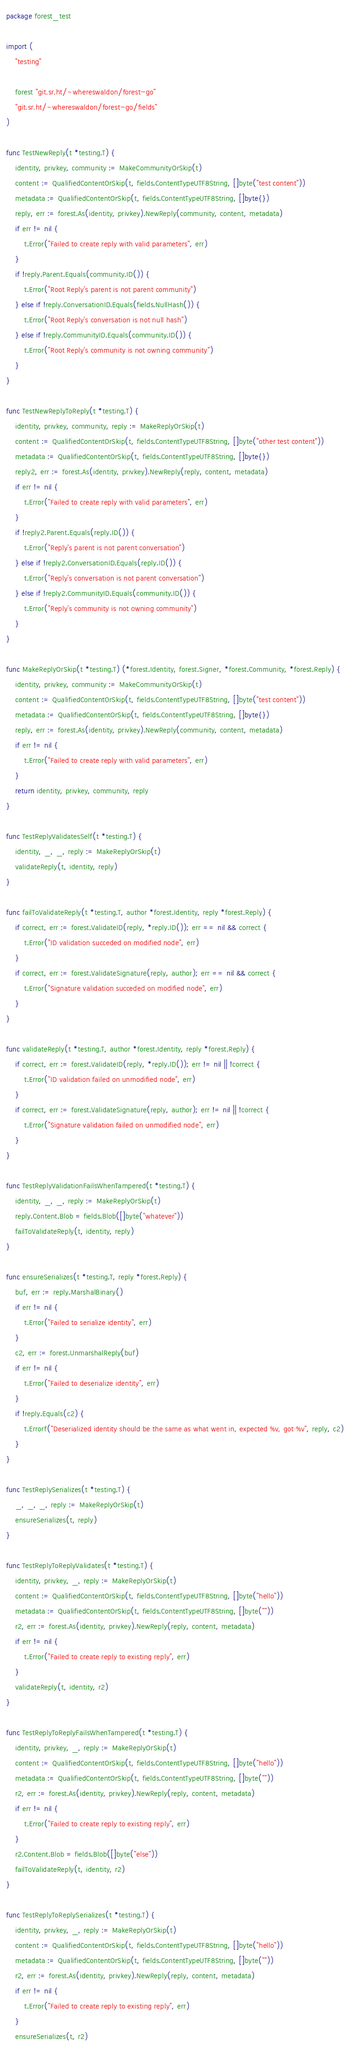Convert code to text. <code><loc_0><loc_0><loc_500><loc_500><_Go_>package forest_test

import (
	"testing"

	forest "git.sr.ht/~whereswaldon/forest-go"
	"git.sr.ht/~whereswaldon/forest-go/fields"
)

func TestNewReply(t *testing.T) {
	identity, privkey, community := MakeCommunityOrSkip(t)
	content := QualifiedContentOrSkip(t, fields.ContentTypeUTF8String, []byte("test content"))
	metadata := QualifiedContentOrSkip(t, fields.ContentTypeUTF8String, []byte{})
	reply, err := forest.As(identity, privkey).NewReply(community, content, metadata)
	if err != nil {
		t.Error("Failed to create reply with valid parameters", err)
	}
	if !reply.Parent.Equals(community.ID()) {
		t.Error("Root Reply's parent is not parent community")
	} else if !reply.ConversationID.Equals(fields.NullHash()) {
		t.Error("Root Reply's conversation is not null hash")
	} else if !reply.CommunityID.Equals(community.ID()) {
		t.Error("Root Reply's community is not owning community")
	}
}

func TestNewReplyToReply(t *testing.T) {
	identity, privkey, community, reply := MakeReplyOrSkip(t)
	content := QualifiedContentOrSkip(t, fields.ContentTypeUTF8String, []byte("other test content"))
	metadata := QualifiedContentOrSkip(t, fields.ContentTypeUTF8String, []byte{})
	reply2, err := forest.As(identity, privkey).NewReply(reply, content, metadata)
	if err != nil {
		t.Error("Failed to create reply with valid parameters", err)
	}
	if !reply2.Parent.Equals(reply.ID()) {
		t.Error("Reply's parent is not parent conversation")
	} else if !reply2.ConversationID.Equals(reply.ID()) {
		t.Error("Reply's conversation is not parent conversation")
	} else if !reply2.CommunityID.Equals(community.ID()) {
		t.Error("Reply's community is not owning community")
	}
}

func MakeReplyOrSkip(t *testing.T) (*forest.Identity, forest.Signer, *forest.Community, *forest.Reply) {
	identity, privkey, community := MakeCommunityOrSkip(t)
	content := QualifiedContentOrSkip(t, fields.ContentTypeUTF8String, []byte("test content"))
	metadata := QualifiedContentOrSkip(t, fields.ContentTypeUTF8String, []byte{})
	reply, err := forest.As(identity, privkey).NewReply(community, content, metadata)
	if err != nil {
		t.Error("Failed to create reply with valid parameters", err)
	}
	return identity, privkey, community, reply
}

func TestReplyValidatesSelf(t *testing.T) {
	identity, _, _, reply := MakeReplyOrSkip(t)
	validateReply(t, identity, reply)
}

func failToValidateReply(t *testing.T, author *forest.Identity, reply *forest.Reply) {
	if correct, err := forest.ValidateID(reply, *reply.ID()); err == nil && correct {
		t.Error("ID validation succeded on modified node", err)
	}
	if correct, err := forest.ValidateSignature(reply, author); err == nil && correct {
		t.Error("Signature validation succeded on modified node", err)
	}
}

func validateReply(t *testing.T, author *forest.Identity, reply *forest.Reply) {
	if correct, err := forest.ValidateID(reply, *reply.ID()); err != nil || !correct {
		t.Error("ID validation failed on unmodified node", err)
	}
	if correct, err := forest.ValidateSignature(reply, author); err != nil || !correct {
		t.Error("Signature validation failed on unmodified node", err)
	}
}

func TestReplyValidationFailsWhenTampered(t *testing.T) {
	identity, _, _, reply := MakeReplyOrSkip(t)
	reply.Content.Blob = fields.Blob([]byte("whatever"))
	failToValidateReply(t, identity, reply)
}

func ensureSerializes(t *testing.T, reply *forest.Reply) {
	buf, err := reply.MarshalBinary()
	if err != nil {
		t.Error("Failed to serialize identity", err)
	}
	c2, err := forest.UnmarshalReply(buf)
	if err != nil {
		t.Error("Failed to deserialize identity", err)
	}
	if !reply.Equals(c2) {
		t.Errorf("Deserialized identity should be the same as what went in, expected %v, got %v", reply, c2)
	}
}

func TestReplySerializes(t *testing.T) {
	_, _, _, reply := MakeReplyOrSkip(t)
	ensureSerializes(t, reply)
}

func TestReplyToReplyValidates(t *testing.T) {
	identity, privkey, _, reply := MakeReplyOrSkip(t)
	content := QualifiedContentOrSkip(t, fields.ContentTypeUTF8String, []byte("hello"))
	metadata := QualifiedContentOrSkip(t, fields.ContentTypeUTF8String, []byte(""))
	r2, err := forest.As(identity, privkey).NewReply(reply, content, metadata)
	if err != nil {
		t.Error("Failed to create reply to existing reply", err)
	}
	validateReply(t, identity, r2)
}

func TestReplyToReplyFailsWhenTampered(t *testing.T) {
	identity, privkey, _, reply := MakeReplyOrSkip(t)
	content := QualifiedContentOrSkip(t, fields.ContentTypeUTF8String, []byte("hello"))
	metadata := QualifiedContentOrSkip(t, fields.ContentTypeUTF8String, []byte(""))
	r2, err := forest.As(identity, privkey).NewReply(reply, content, metadata)
	if err != nil {
		t.Error("Failed to create reply to existing reply", err)
	}
	r2.Content.Blob = fields.Blob([]byte("else"))
	failToValidateReply(t, identity, r2)
}

func TestReplyToReplySerializes(t *testing.T) {
	identity, privkey, _, reply := MakeReplyOrSkip(t)
	content := QualifiedContentOrSkip(t, fields.ContentTypeUTF8String, []byte("hello"))
	metadata := QualifiedContentOrSkip(t, fields.ContentTypeUTF8String, []byte(""))
	r2, err := forest.As(identity, privkey).NewReply(reply, content, metadata)
	if err != nil {
		t.Error("Failed to create reply to existing reply", err)
	}
	ensureSerializes(t, r2)</code> 